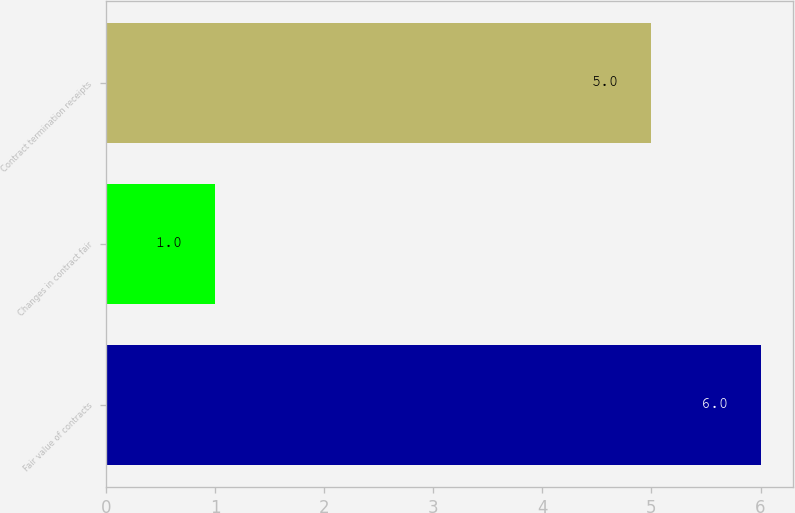Convert chart to OTSL. <chart><loc_0><loc_0><loc_500><loc_500><bar_chart><fcel>Fair value of contracts<fcel>Changes in contract fair<fcel>Contract termination receipts<nl><fcel>6<fcel>1<fcel>5<nl></chart> 